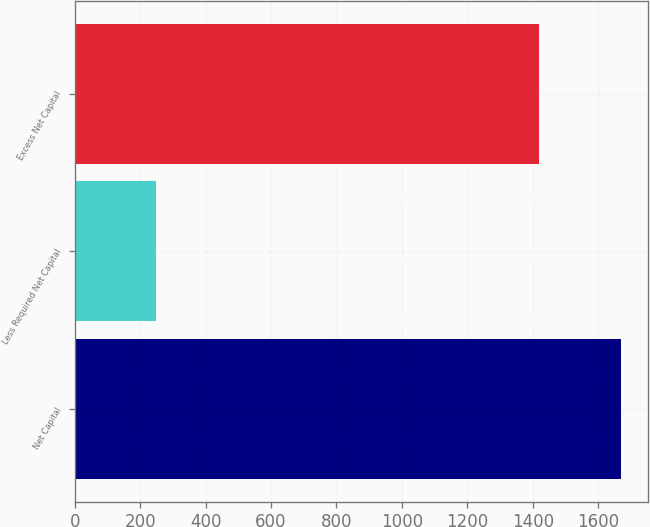<chart> <loc_0><loc_0><loc_500><loc_500><bar_chart><fcel>Net Capital<fcel>Less Required Net Capital<fcel>Excess Net Capital<nl><fcel>1669<fcel>250<fcel>1419<nl></chart> 